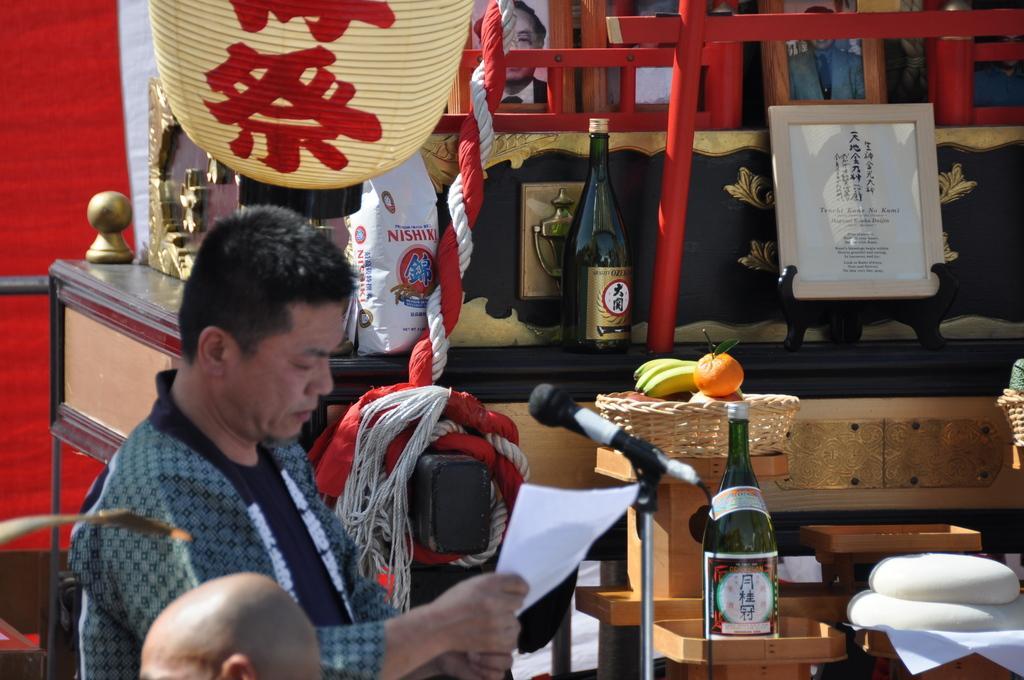How would you summarize this image in a sentence or two? In the image there is a man stood on left side, in front of him there is a mic and on the backside there are wine bottles and photo frames and a basket full of fruits. 